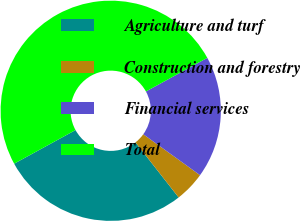Convert chart to OTSL. <chart><loc_0><loc_0><loc_500><loc_500><pie_chart><fcel>Agriculture and turf<fcel>Construction and forestry<fcel>Financial services<fcel>Total<nl><fcel>27.6%<fcel>4.48%<fcel>17.92%<fcel>50.0%<nl></chart> 